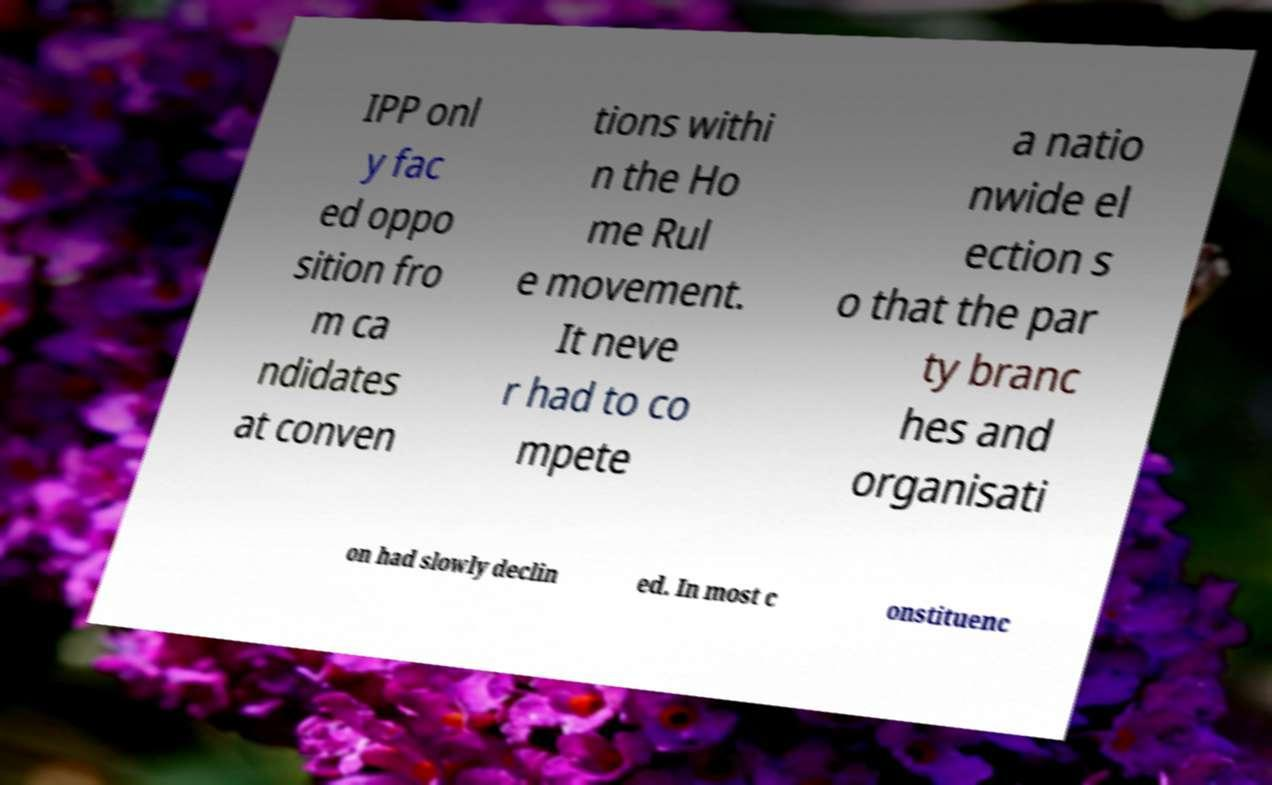I need the written content from this picture converted into text. Can you do that? IPP onl y fac ed oppo sition fro m ca ndidates at conven tions withi n the Ho me Rul e movement. It neve r had to co mpete a natio nwide el ection s o that the par ty branc hes and organisati on had slowly declin ed. In most c onstituenc 